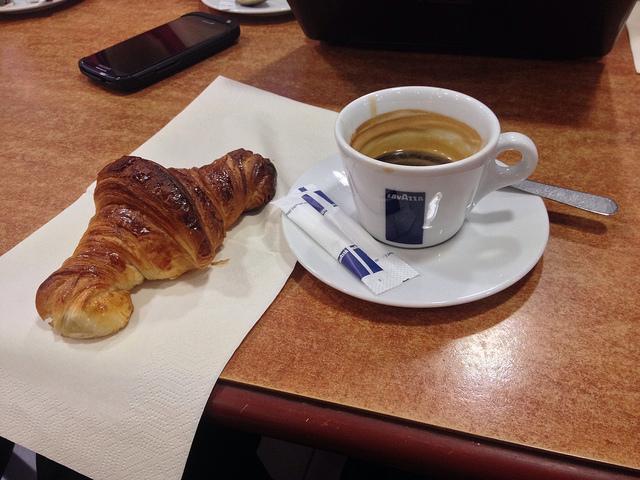How many place settings are visible?
Give a very brief answer. 1. How many sugar packets are on the plate?
Give a very brief answer. 2. How many cups are in the photo?
Give a very brief answer. 1. How many chairs or sofas have a red pillow?
Give a very brief answer. 0. 